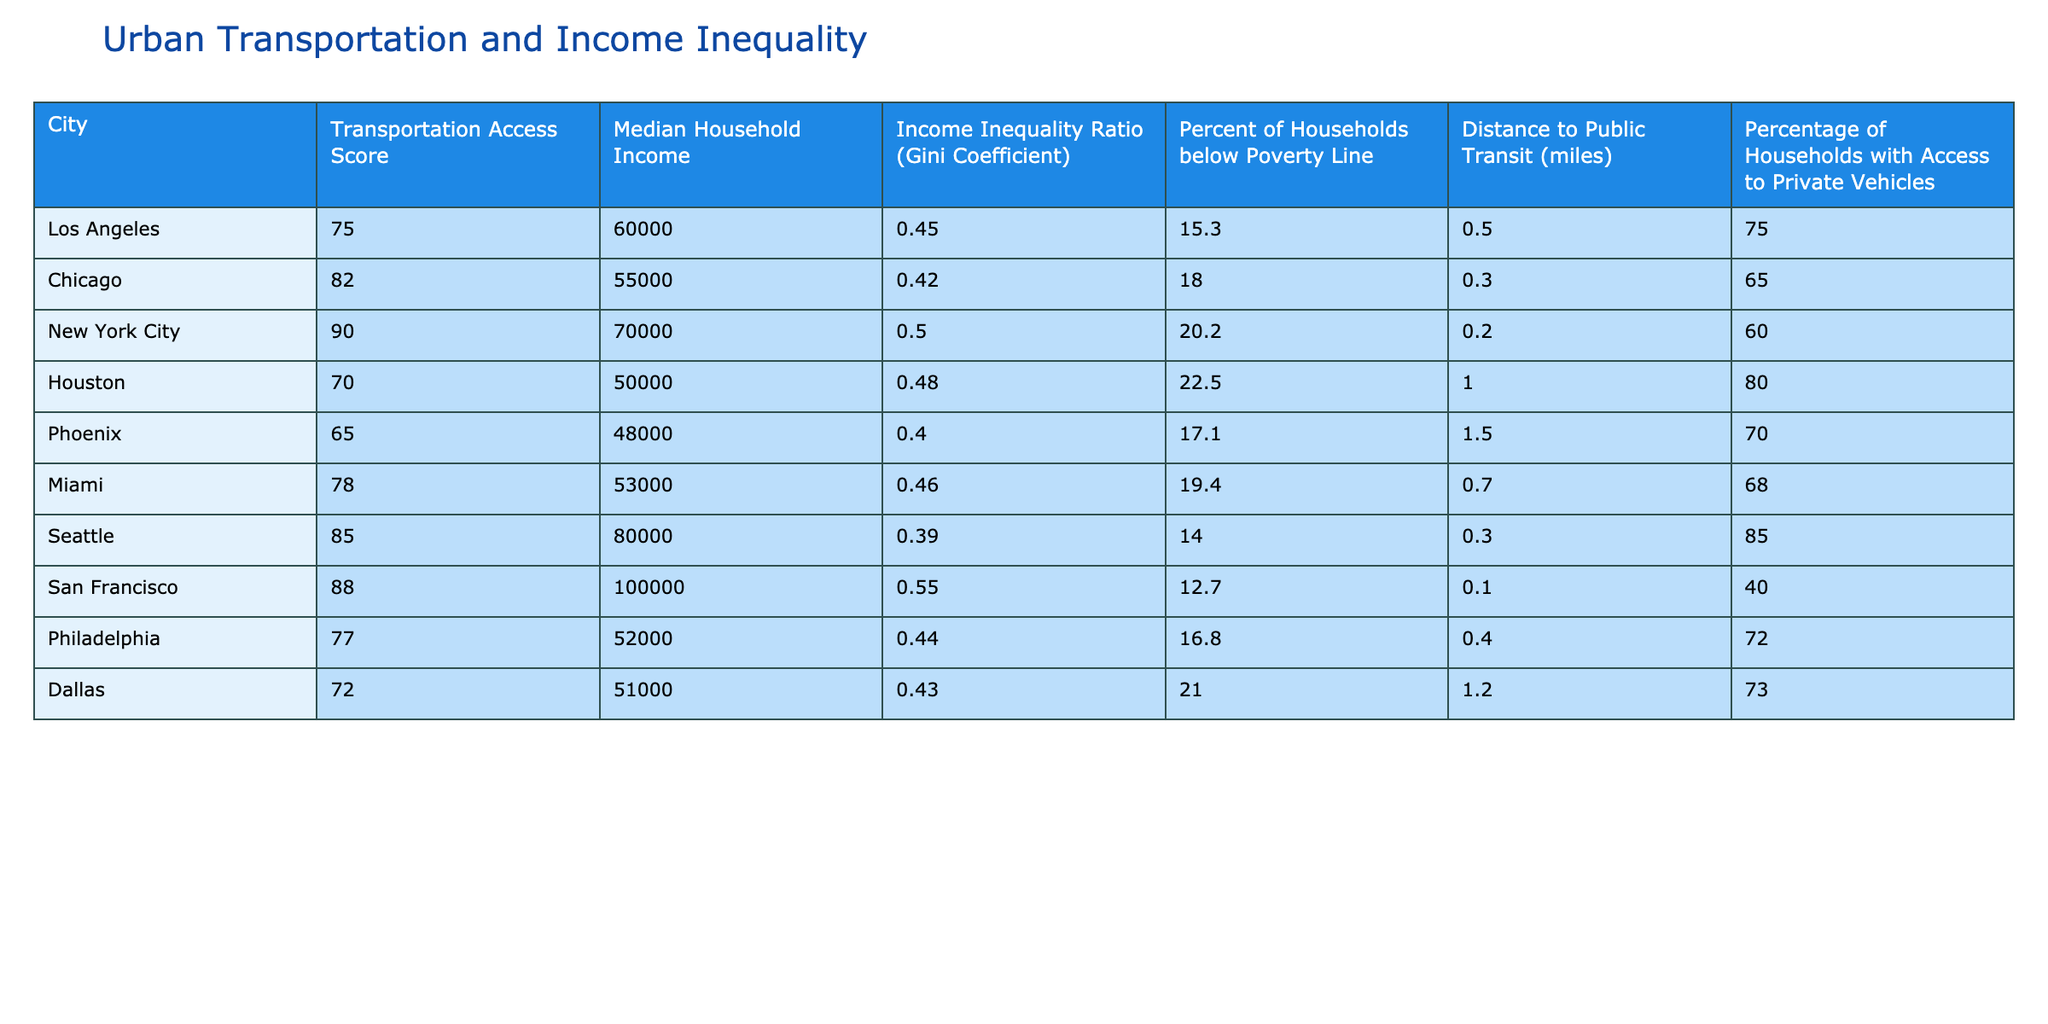What is the median household income in Seattle? The median household income in Seattle can be found directly in the table. It is listed under the "Median Household Income" column for Seattle.
Answer: 80000 Which city has the highest income inequality ratio (Gini Coefficient)? The table lists the Gini Coefficient for each city. By scanning the column, we find that San Francisco has the highest Gini Coefficient of 0.55.
Answer: San Francisco What is the average Transportation Access Score for cities with an income inequality ratio below 0.45? First, we identify the cities with a Gini Coefficient below 0.45, which are Seattle (0.39), and Miami (0.46). Then we find the Transportation Access Scores for those cities: Seattle (85) and Miami (78). To find the average, we calculate (85 + 78) / 2 = 81.5.
Answer: 81.5 Are there any cities where the percentage of households below the poverty line is higher than 20%? We need to check the "Percent of Households below Poverty Line" column for each city. Scanning through the values, Houston (22.5%) and New York City (20.2%) both exceed 20%. Therefore, the answer is yes, as there are cities that meet this condition.
Answer: Yes What is the difference in median household income between New York City and Houston? To answer this, we subtract Houston's median household income from New York City's. New York City's median household income is 70000 and Houston's is 50000. The difference is 70000 - 50000 = 20000.
Answer: 20000 What percentage of households have access to private vehicles in Dallas? The table directly states the percentage of households with access to private vehicles in Dallas. This information is under the "Percentage of Households with Access to Private Vehicles" column for Dallas.
Answer: 73 Which city has the shortest distance to public transit, and what is that distance? We examine the "Distance to Public Transit" column and find the shortest distance, which is for San Francisco at 0.1 miles. San Francisco is also noted as the city with the highest income at the same time.
Answer: San Francisco, 0.1 miles What is the total percentage of households below the poverty line for all cities listed? To determine the total percentage, we would sum the percentages in the "Percent of Households below Poverty Line" column. The sum is: 15.3 + 18 + 20.2 + 22.5 + 17.1 + 19.4 + 14 + 12.7 + 16.8 + 21 =  175. There are ten cities, so the average would be 175 / 10 = 17.5.
Answer: 175 Is the transportation access score in Los Angeles higher than that in Houston? By comparing the "Transportation Access Score" for Los Angeles (75) and Houston (70), we see that Los Angeles has a higher score. Therefore, the answer to the question is yes.
Answer: Yes 